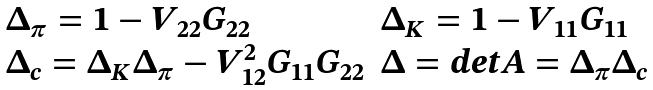Convert formula to latex. <formula><loc_0><loc_0><loc_500><loc_500>\begin{array} { l l } \Delta _ { \pi } = 1 - V _ { 2 2 } G _ { 2 2 } & \Delta _ { K } = 1 - V _ { 1 1 } G _ { 1 1 } \\ \Delta _ { c } = \Delta _ { K } \Delta _ { \pi } - V _ { 1 2 } ^ { 2 } G _ { 1 1 } G _ { 2 2 } & \Delta = d e t A = \Delta _ { \pi } \Delta _ { c } \end{array}</formula> 